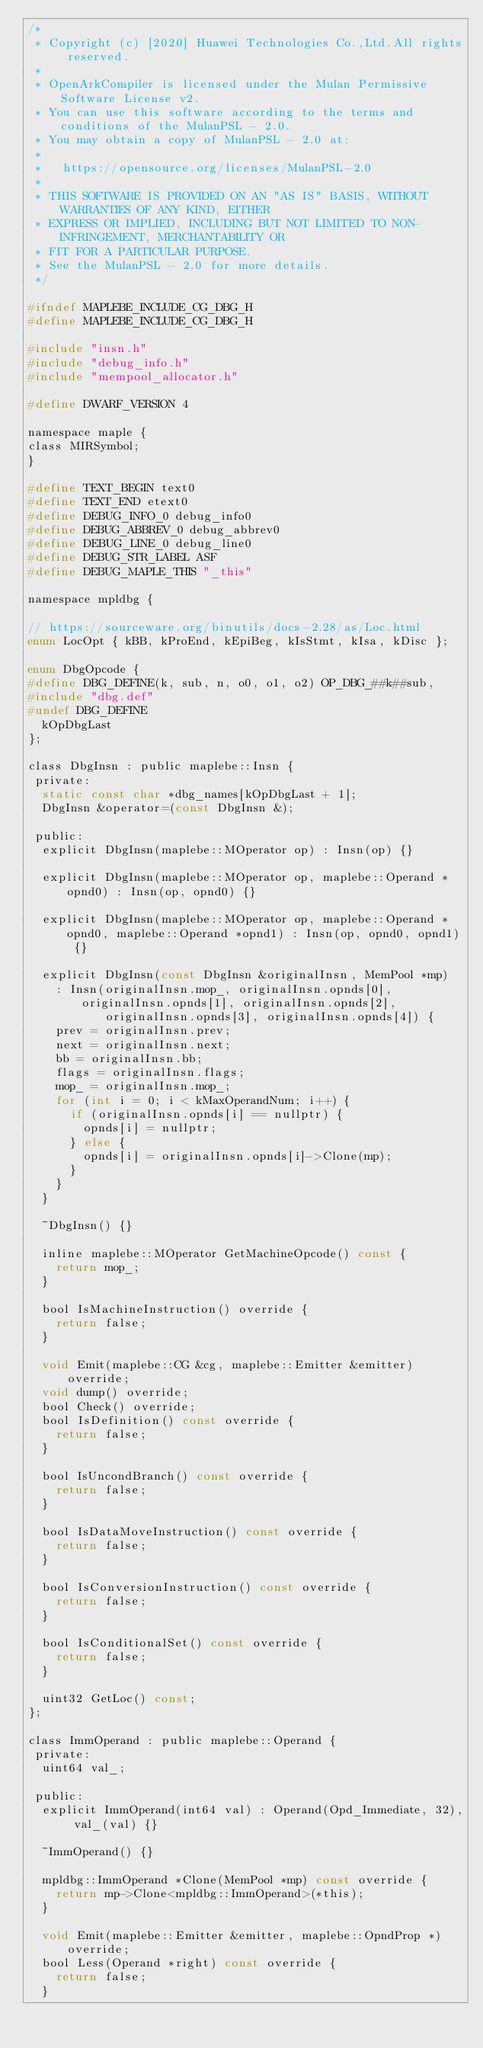<code> <loc_0><loc_0><loc_500><loc_500><_C_>/*
 * Copyright (c) [2020] Huawei Technologies Co.,Ltd.All rights reserved.
 *
 * OpenArkCompiler is licensed under the Mulan Permissive Software License v2.
 * You can use this software according to the terms and conditions of the MulanPSL - 2.0.
 * You may obtain a copy of MulanPSL - 2.0 at:
 *
 *   https://opensource.org/licenses/MulanPSL-2.0
 *
 * THIS SOFTWARE IS PROVIDED ON AN "AS IS" BASIS, WITHOUT WARRANTIES OF ANY KIND, EITHER
 * EXPRESS OR IMPLIED, INCLUDING BUT NOT LIMITED TO NON-INFRINGEMENT, MERCHANTABILITY OR
 * FIT FOR A PARTICULAR PURPOSE.
 * See the MulanPSL - 2.0 for more details.
 */

#ifndef MAPLEBE_INCLUDE_CG_DBG_H
#define MAPLEBE_INCLUDE_CG_DBG_H

#include "insn.h"
#include "debug_info.h"
#include "mempool_allocator.h"

#define DWARF_VERSION 4

namespace maple {
class MIRSymbol;
}

#define TEXT_BEGIN text0
#define TEXT_END etext0
#define DEBUG_INFO_0 debug_info0
#define DEBUG_ABBREV_0 debug_abbrev0
#define DEBUG_LINE_0 debug_line0
#define DEBUG_STR_LABEL ASF
#define DEBUG_MAPLE_THIS "_this"

namespace mpldbg {

// https://sourceware.org/binutils/docs-2.28/as/Loc.html
enum LocOpt { kBB, kProEnd, kEpiBeg, kIsStmt, kIsa, kDisc };

enum DbgOpcode {
#define DBG_DEFINE(k, sub, n, o0, o1, o2) OP_DBG_##k##sub,
#include "dbg.def"
#undef DBG_DEFINE
  kOpDbgLast
};

class DbgInsn : public maplebe::Insn {
 private:
  static const char *dbg_names[kOpDbgLast + 1];
  DbgInsn &operator=(const DbgInsn &);

 public:
  explicit DbgInsn(maplebe::MOperator op) : Insn(op) {}

  explicit DbgInsn(maplebe::MOperator op, maplebe::Operand *opnd0) : Insn(op, opnd0) {}

  explicit DbgInsn(maplebe::MOperator op, maplebe::Operand *opnd0, maplebe::Operand *opnd1) : Insn(op, opnd0, opnd1) {}

  explicit DbgInsn(const DbgInsn &originalInsn, MemPool *mp)
    : Insn(originalInsn.mop_, originalInsn.opnds[0], originalInsn.opnds[1], originalInsn.opnds[2],
           originalInsn.opnds[3], originalInsn.opnds[4]) {
    prev = originalInsn.prev;
    next = originalInsn.next;
    bb = originalInsn.bb;
    flags = originalInsn.flags;
    mop_ = originalInsn.mop_;
    for (int i = 0; i < kMaxOperandNum; i++) {
      if (originalInsn.opnds[i] == nullptr) {
        opnds[i] = nullptr;
      } else {
        opnds[i] = originalInsn.opnds[i]->Clone(mp);
      }
    }
  }

  ~DbgInsn() {}

  inline maplebe::MOperator GetMachineOpcode() const {
    return mop_;
  }

  bool IsMachineInstruction() override {
    return false;
  }

  void Emit(maplebe::CG &cg, maplebe::Emitter &emitter) override;
  void dump() override;
  bool Check() override;
  bool IsDefinition() const override {
    return false;
  }

  bool IsUncondBranch() const override {
    return false;
  }

  bool IsDataMoveInstruction() const override {
    return false;
  }

  bool IsConversionInstruction() const override {
    return false;
  }

  bool IsConditionalSet() const override {
    return false;
  }

  uint32 GetLoc() const;
};

class ImmOperand : public maplebe::Operand {
 private:
  uint64 val_;

 public:
  explicit ImmOperand(int64 val) : Operand(Opd_Immediate, 32), val_(val) {}

  ~ImmOperand() {}

  mpldbg::ImmOperand *Clone(MemPool *mp) const override {
    return mp->Clone<mpldbg::ImmOperand>(*this);
  }

  void Emit(maplebe::Emitter &emitter, maplebe::OpndProp *) override;
  bool Less(Operand *right) const override {
    return false;
  }
</code> 